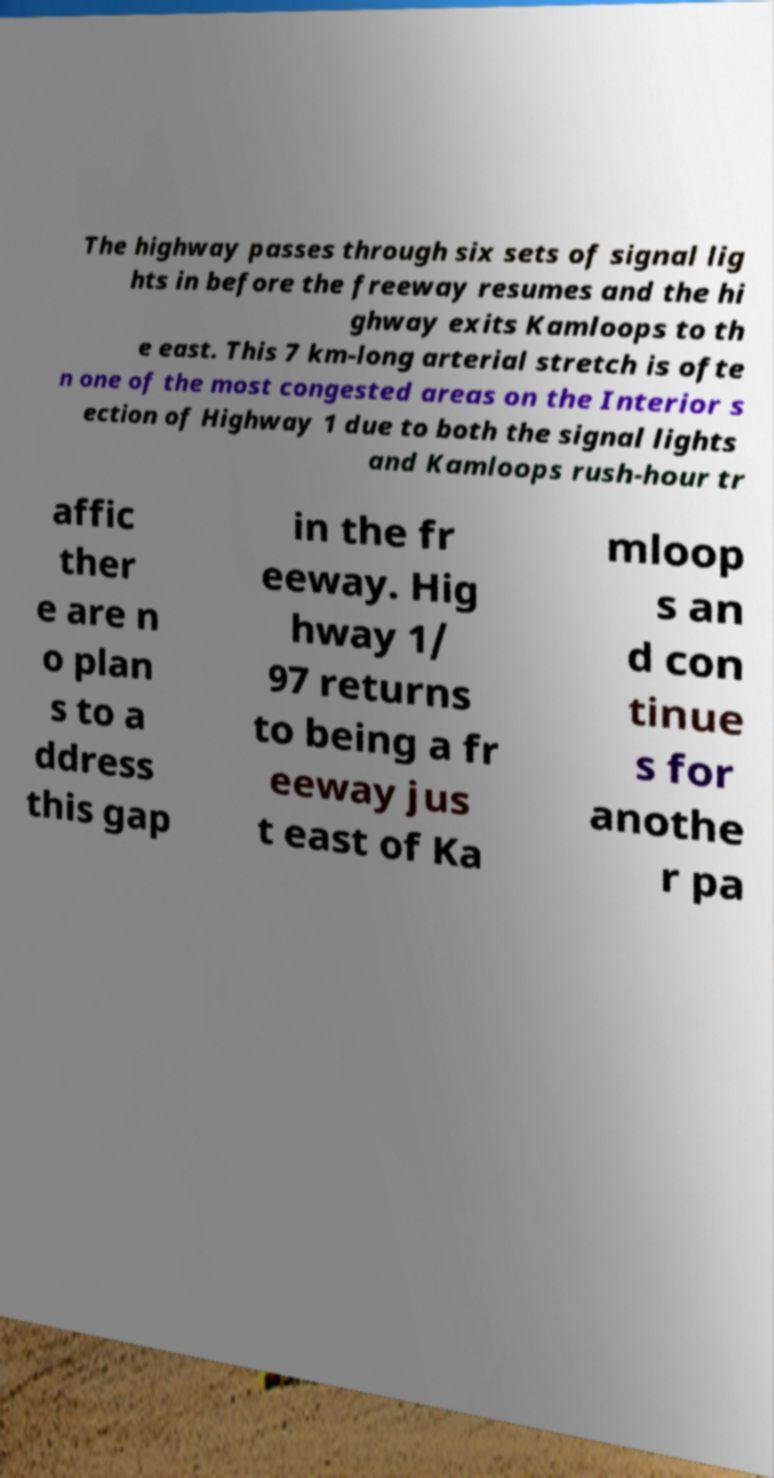Please read and relay the text visible in this image. What does it say? The highway passes through six sets of signal lig hts in before the freeway resumes and the hi ghway exits Kamloops to th e east. This 7 km-long arterial stretch is ofte n one of the most congested areas on the Interior s ection of Highway 1 due to both the signal lights and Kamloops rush-hour tr affic ther e are n o plan s to a ddress this gap in the fr eeway. Hig hway 1/ 97 returns to being a fr eeway jus t east of Ka mloop s an d con tinue s for anothe r pa 